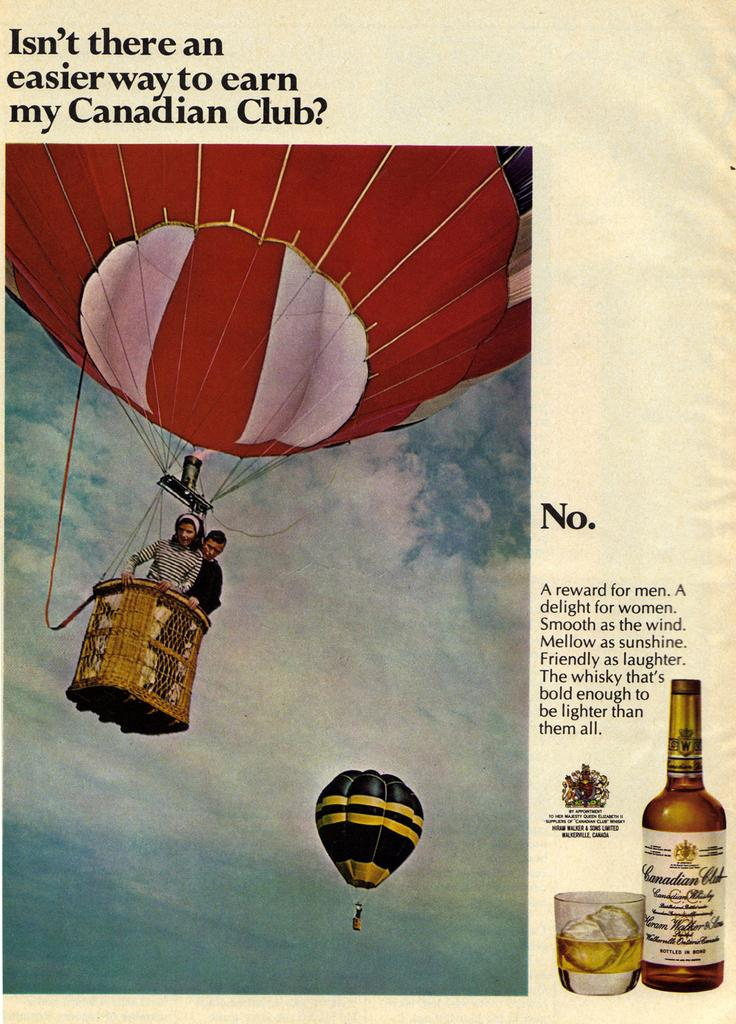<image>
Write a terse but informative summary of the picture. a paper with my Canadian Club on it 